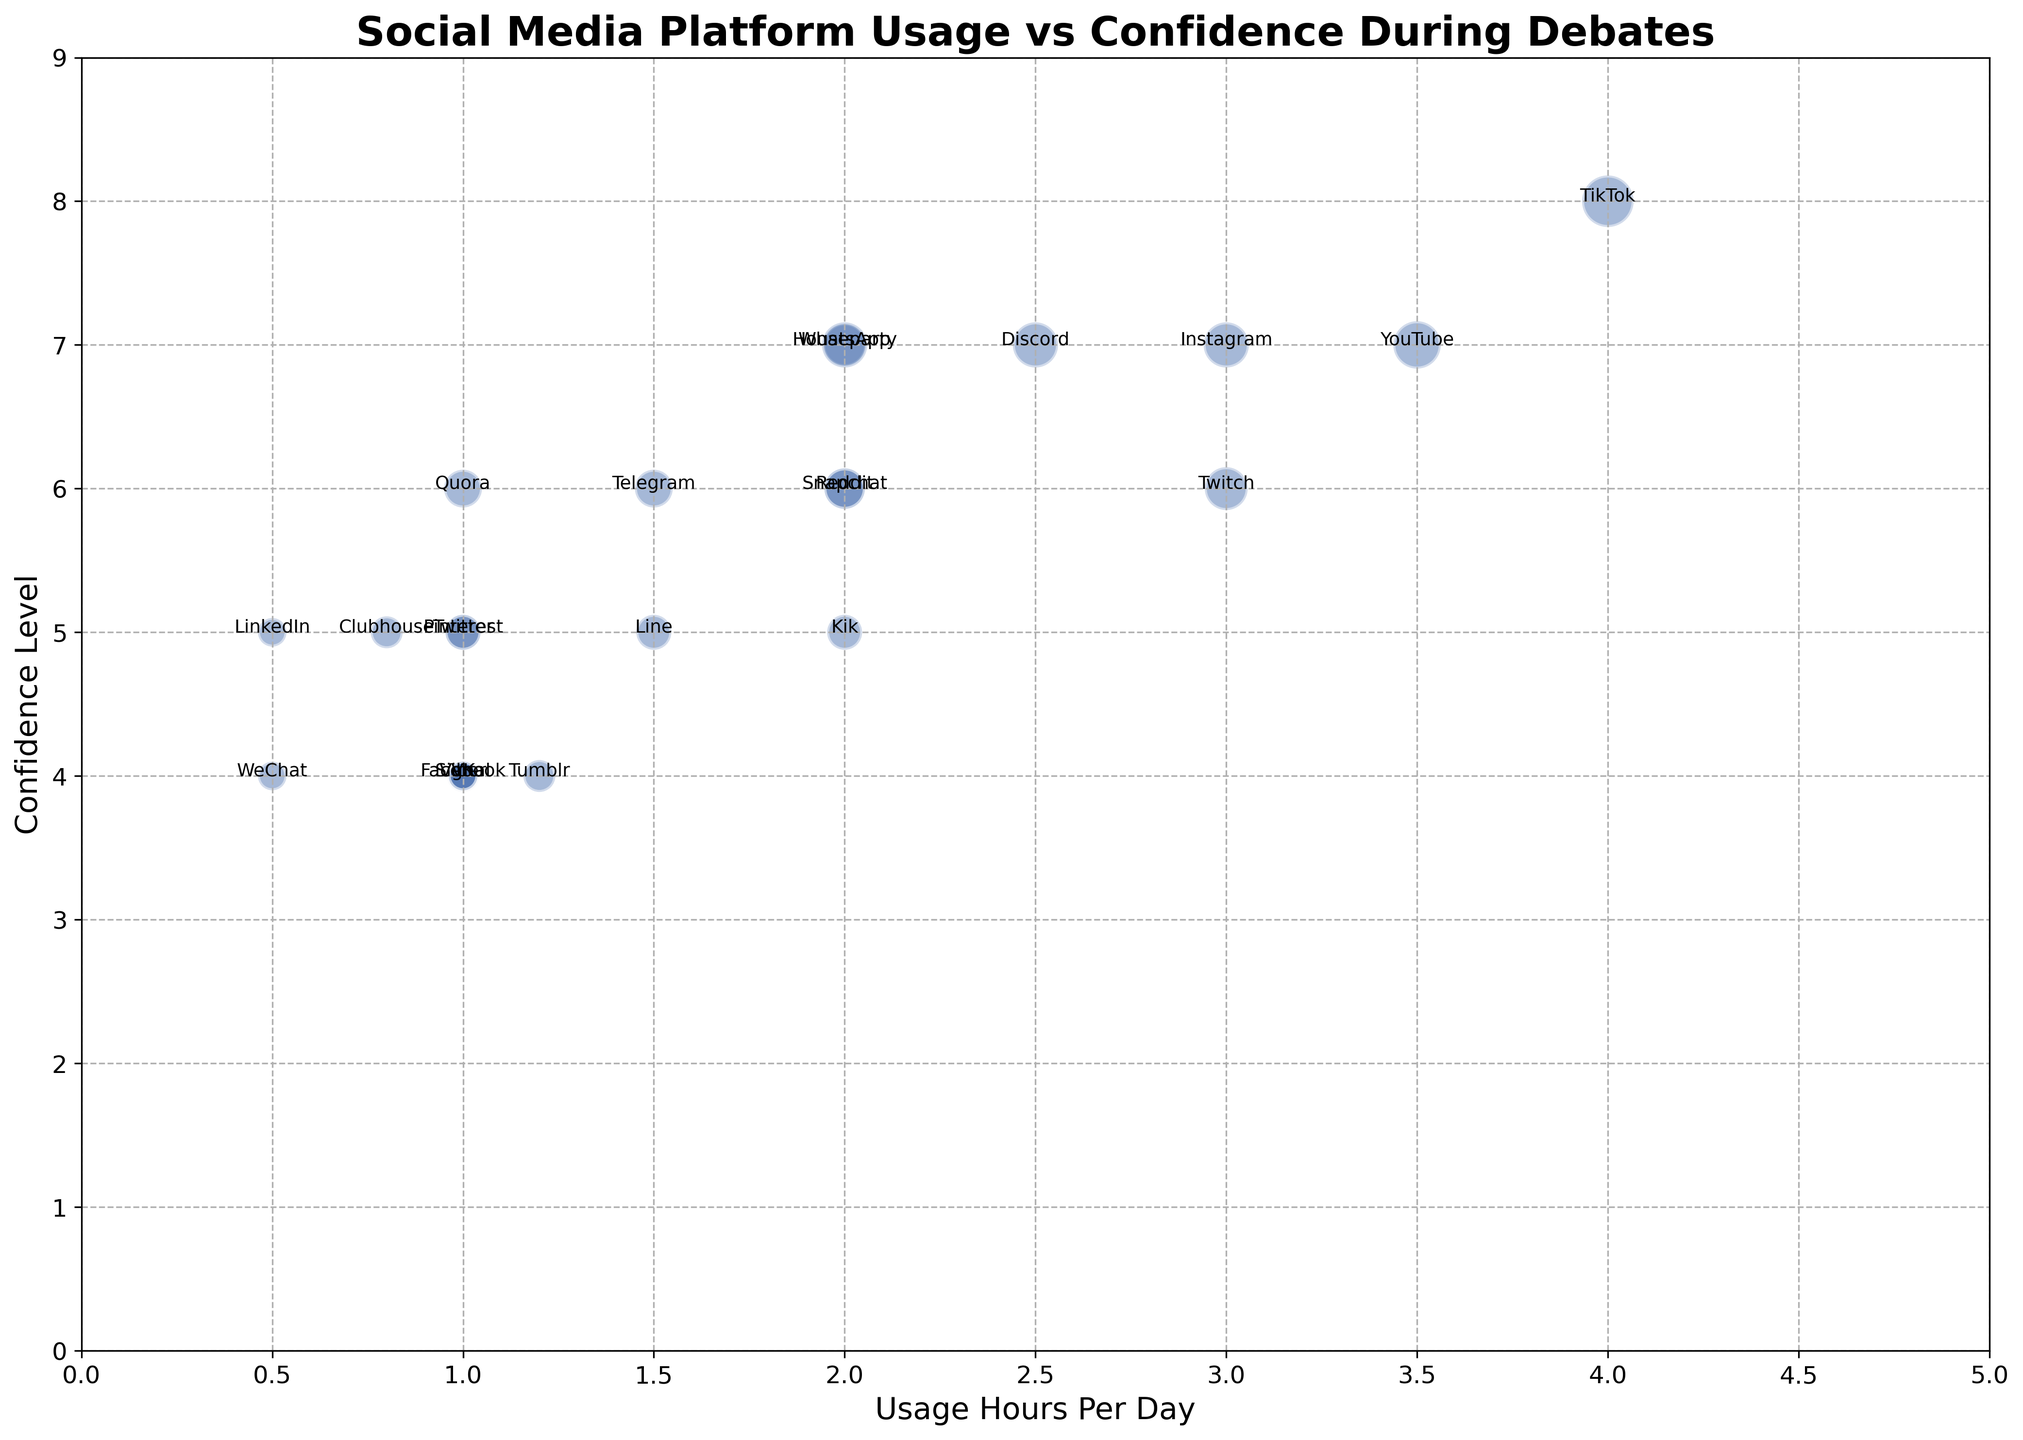Which platform has the highest reported confidence level? By observing the vertical axis (Confidence Level) on the chart, we see that the highest point on that axis corresponds to the platform "TikTok" with a confidence level of 8.
Answer: TikTok Which social media platforms have a confidence level of 6, and how many are there? By looking at the points aligned with the confidence level of 6 on the vertical axis, we observe that multiple platforms fall under this category: Snapchat, Telegram, Reddit, Quora, and Twitch. Counting these gives us a total of 5 platforms.
Answer: 5 (Snapchat, Telegram, Reddit, Quora, Twitch) What is the average usage hours per day for platforms with a confidence level of 7? Platforms with confidence level 7 are Instagram, WhatsApp, YouTube, Discord, and Houseparty. Their usage hours are 3, 2, 3.5, 2.5, and 2 respectively. The sum of these values is 13, and as there are 5 data points, the average is 13 / 5 = 2.6.
Answer: 2.6 Which platform has the smallest bubble size? Observing the size of the bubbles on the chart, the smallest ones are clearly linked to the platforms "LinkedIn" and "WeChat", each with a bubble size of 20.
Answer: LinkedIn, WeChat Compare the usage hours per day between Instagram and YouTube. Which one is higher and by how much? From the chart, Instagram's usage hours per day is 3, while YouTube's is 3.5. Subtracting these gives 3.5 - 3 = 0.5, showing that YouTube has higher usage by 0.5 hours.
Answer: YouTube by 0.5 hours Is there any platform with a usage hours per day greater than 4? Examining the horizontal axis (Usage Hours Per Day), we see that the only bubble positioned greater than 4 hours is TikTok, at 4 hours.
Answer: TikTok Identify three platforms with the same confidence level and different usage hours per day. Sorting through the chart, platforms with the same confidence level include Snapchat, Telegram, and Twitch, all with confidence level 6 but different usage hours: 2, 1.5, and 3 respectively.
Answer: Snapchat, Telegram, Twitch What is the total bubble size for platforms with confidence level 5? Platforms with confidence level 5 are Twitter, LinkedIn, Pinterest, Line, and Clubhouse, with bubble sizes 30, 20, 30, 30, and 25 respectively. The total bubble size is 30 + 20 + 30 + 30 + 25 = 135.
Answer: 135 Between Snapchat and Reddit, which has a greater confidence level, and by how much? From the chart, Snapchat has a confidence level of 6, while Reddit has the same confidence level of 6. The difference is therefore 6 - 6 = 0.
Answer: Equal, by 0 Which platform(s) report lower confidence levels with higher usage hours per day? Scanning the chart for lower confidence levels (e.g., 4) with relatively higher usage, we find that Facebook and Twitch both have confidence levels of 4 with usage hours of 1 hour each, which is not "higher" compared to the rest of the data range. Therefore, there are no such platforms where both conditions meet.
Answer: None 